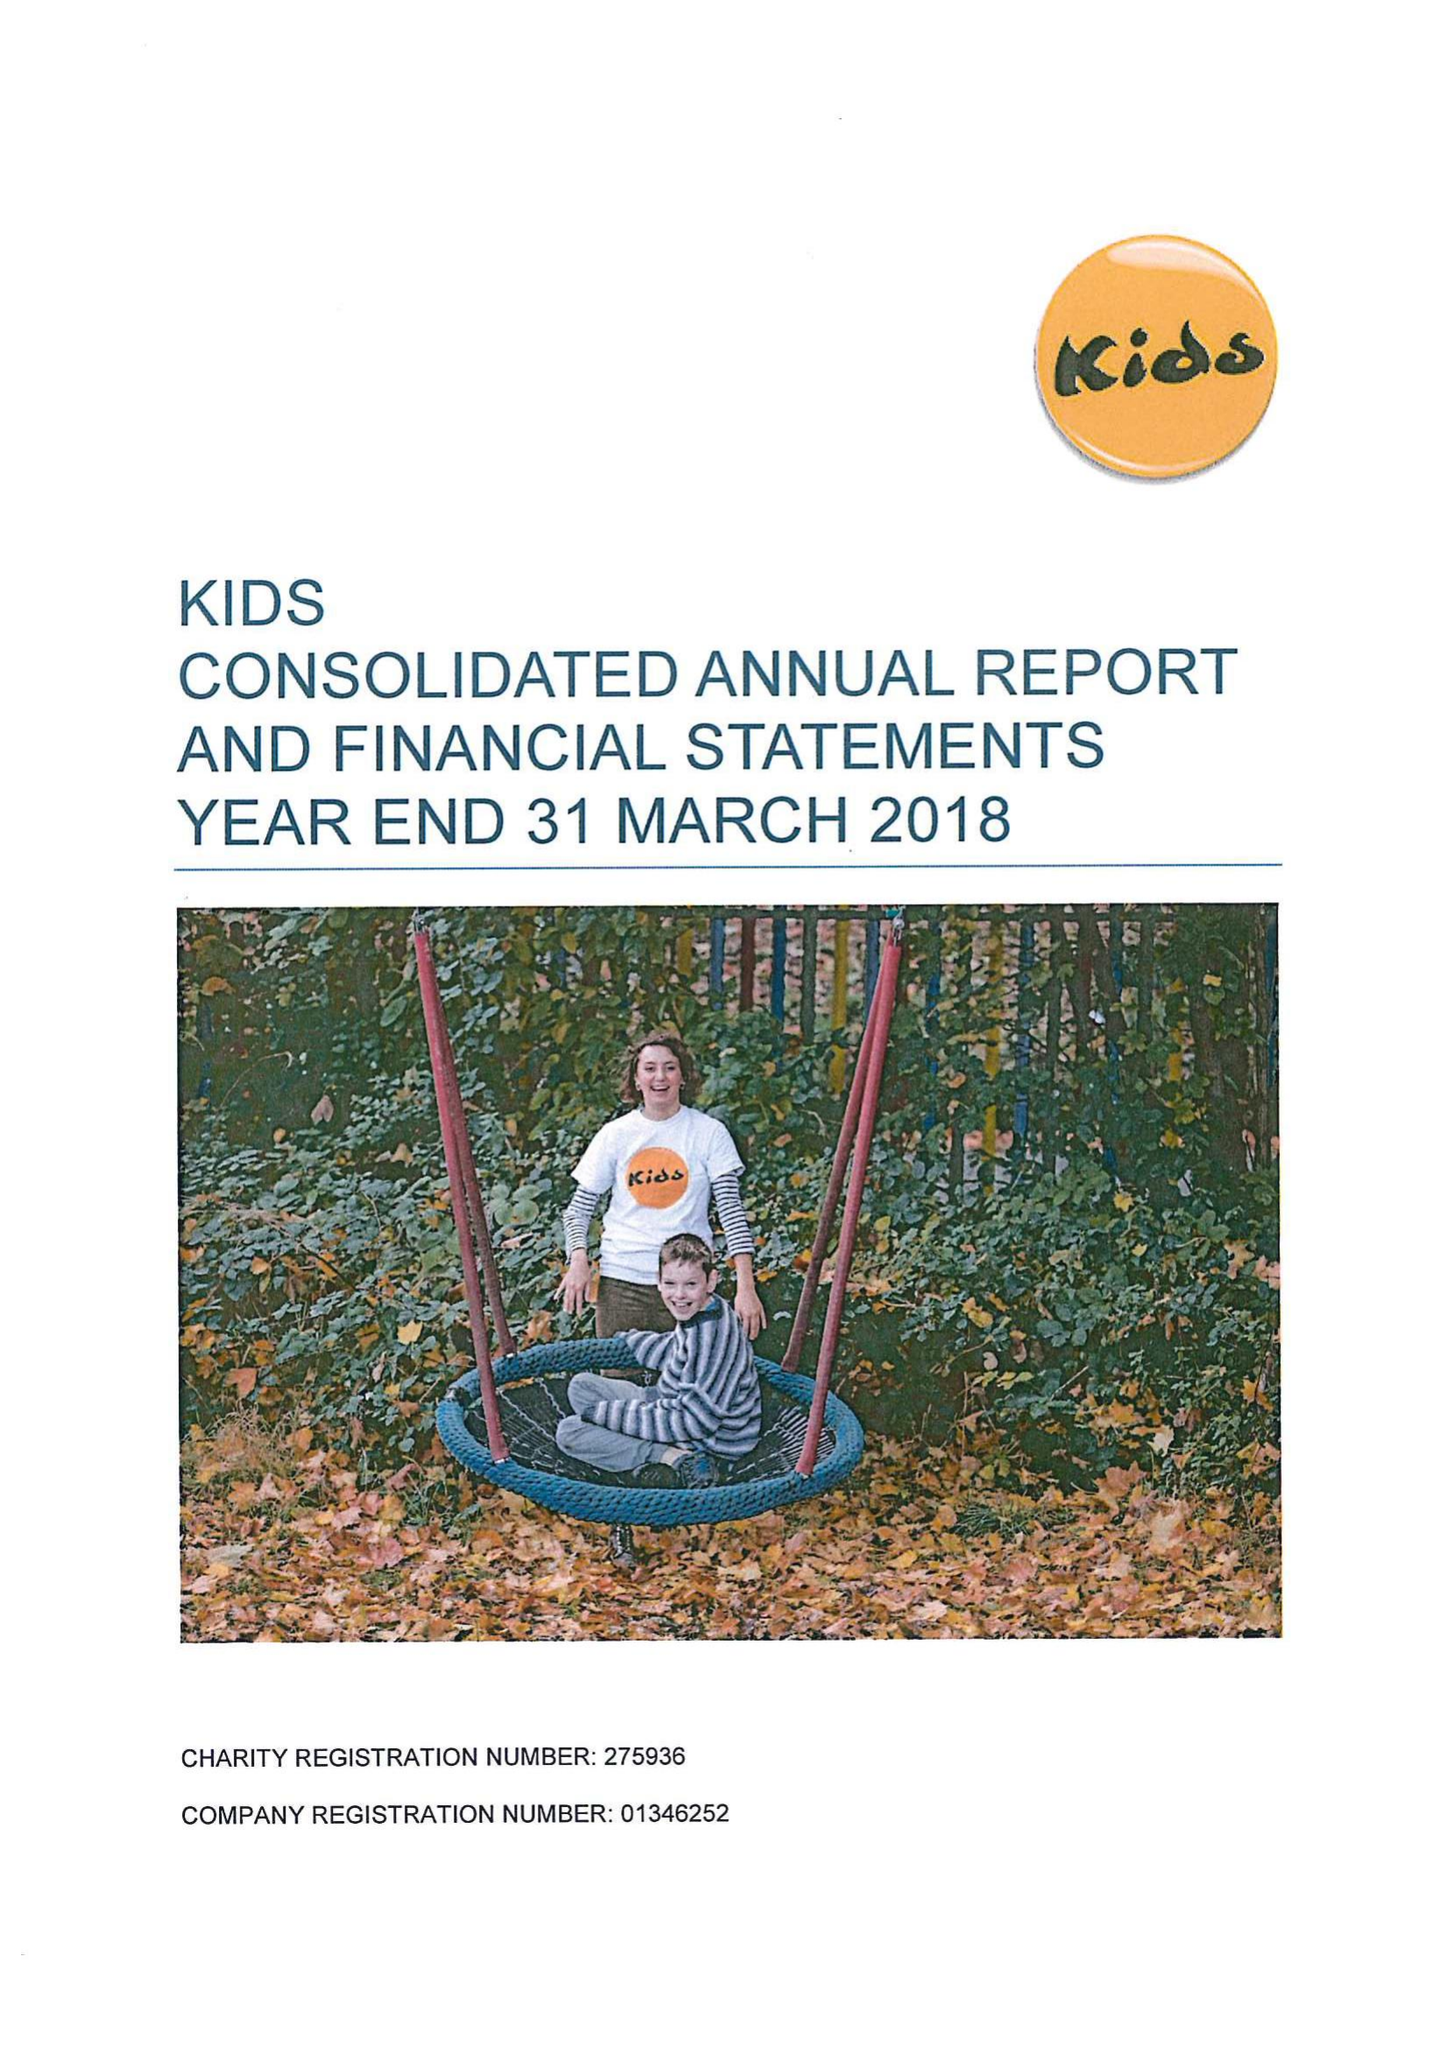What is the value for the spending_annually_in_british_pounds?
Answer the question using a single word or phrase. 10734349.00 